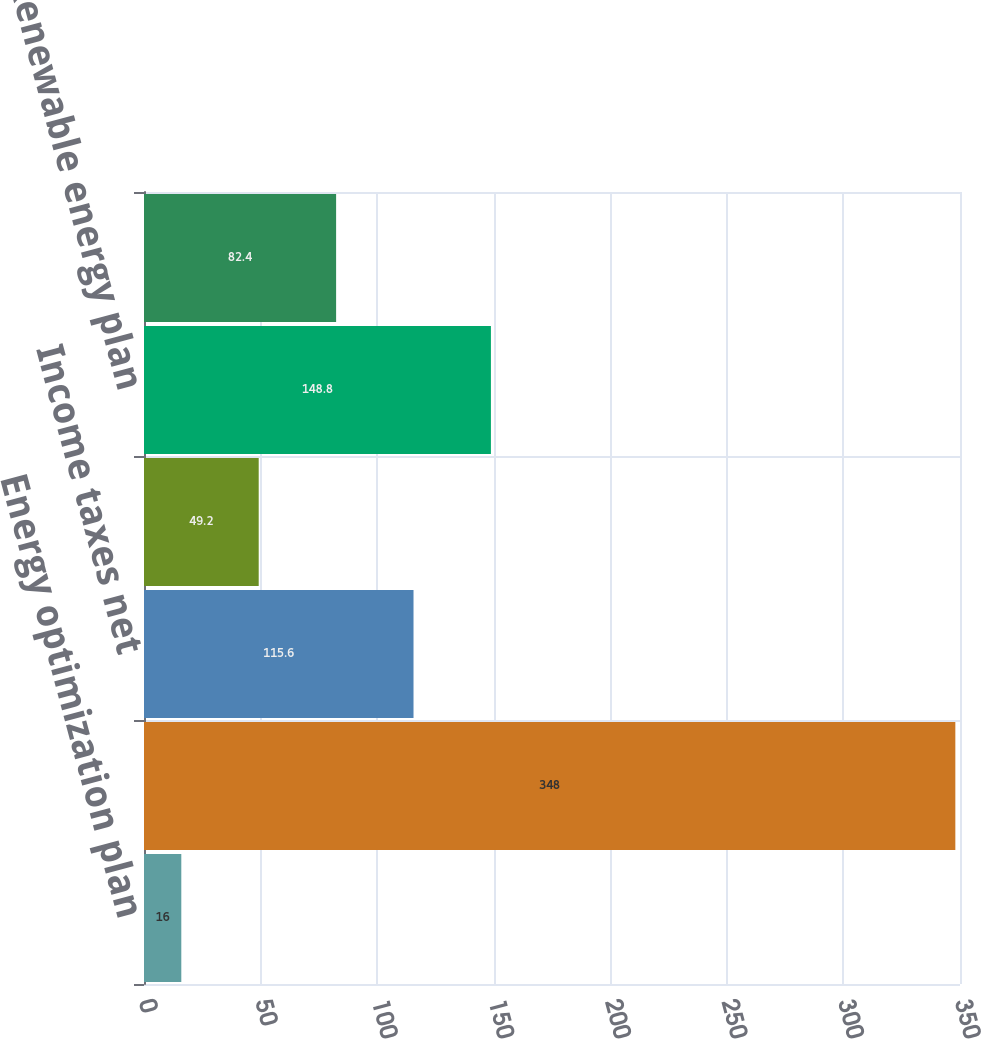Convert chart to OTSL. <chart><loc_0><loc_0><loc_500><loc_500><bar_chart><fcel>Energy optimization plan<fcel>Securitized costs 3<fcel>Income taxes net<fcel>Reserve for customer refunds<fcel>Renewable energy plan<fcel>Renewable energy grant<nl><fcel>16<fcel>348<fcel>115.6<fcel>49.2<fcel>148.8<fcel>82.4<nl></chart> 